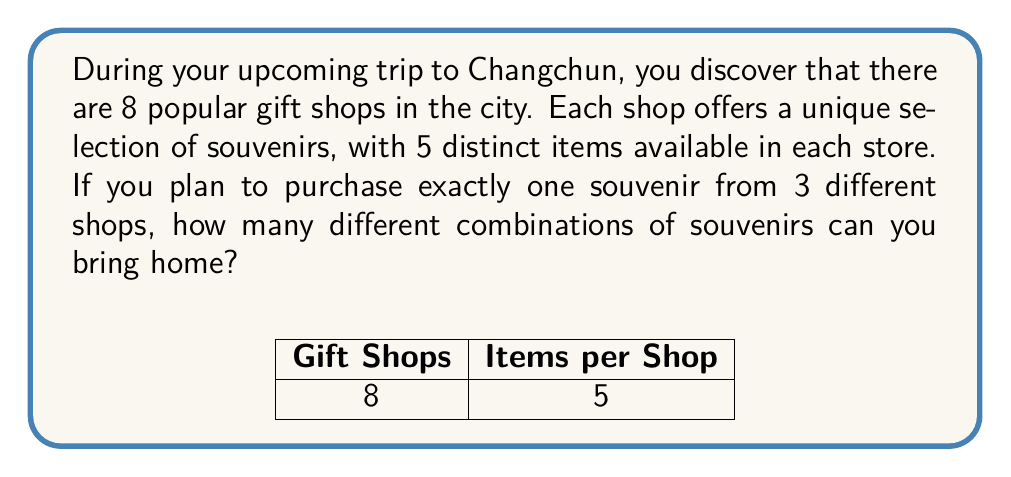Can you solve this math problem? Let's approach this problem step-by-step using combination theory:

1) First, we need to choose 3 shops out of the 8 available. This can be done in $\binom{8}{3}$ ways.

2) The number of ways to choose 3 shops out of 8 is calculated as:

   $$\binom{8}{3} = \frac{8!}{3!(8-3)!} = \frac{8!}{3!5!} = 56$$

3) Now, for each of these 56 combinations of shops, we need to choose one item from each shop.

4) Each shop has 5 distinct items, and we're choosing one item from each of the 3 selected shops.

5) This is a multiplication principle scenario. For each shop selection, we have 5 choices for the first shop, 5 for the second, and 5 for the third.

6) So, for each combination of 3 shops, we have $5 \times 5 \times 5 = 5^3 = 125$ possible combinations of souvenirs.

7) To get the total number of distinct souvenir combinations, we multiply the number of shop combinations by the number of souvenir combinations per shop selection:

   $$56 \times 125 = 7,000$$

Therefore, there are 7,000 different combinations of souvenirs you can bring home.
Answer: 7,000 combinations 